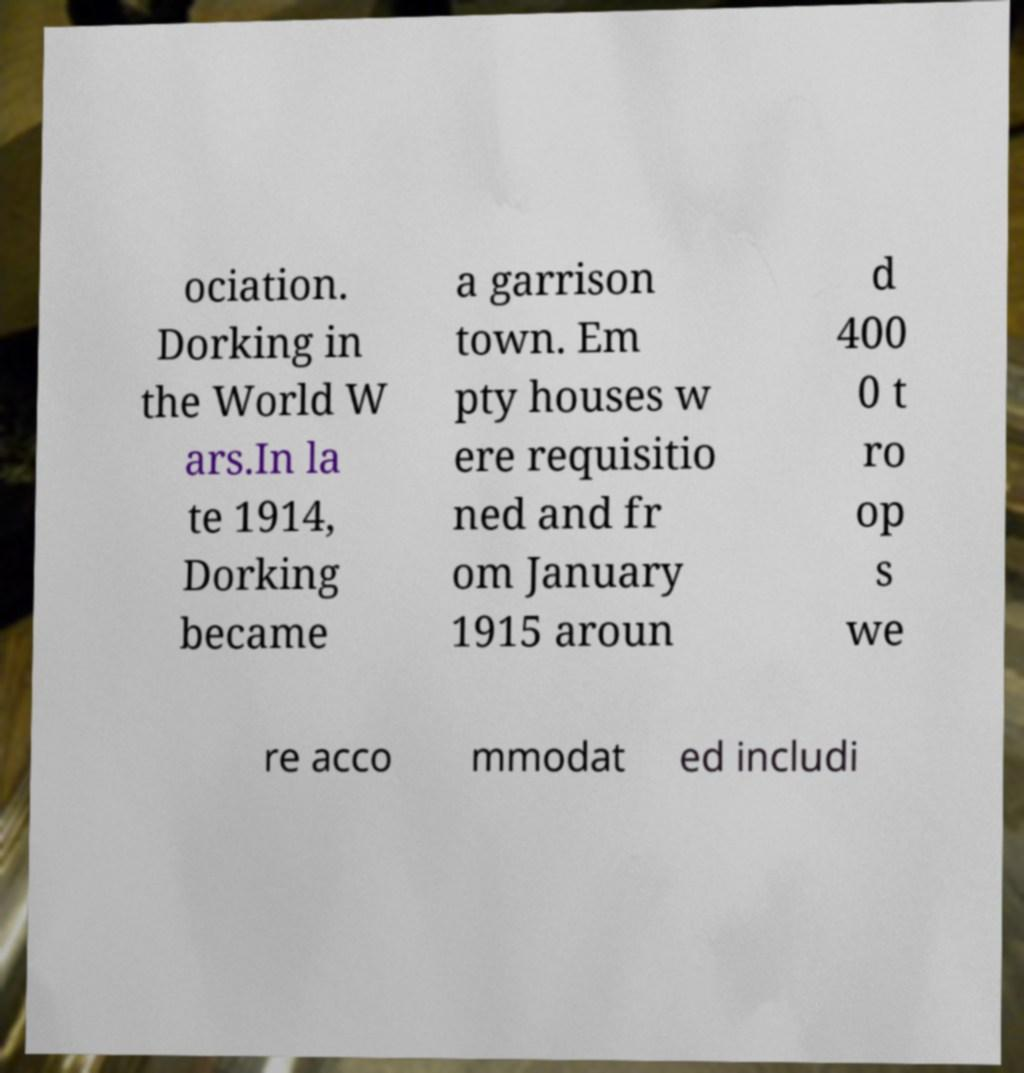Please identify and transcribe the text found in this image. ociation. Dorking in the World W ars.In la te 1914, Dorking became a garrison town. Em pty houses w ere requisitio ned and fr om January 1915 aroun d 400 0 t ro op s we re acco mmodat ed includi 